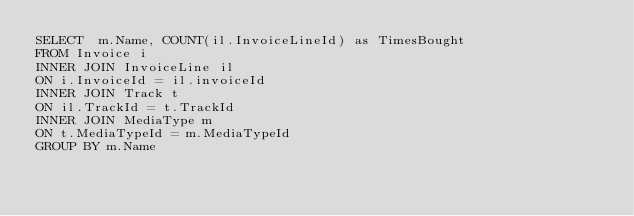Convert code to text. <code><loc_0><loc_0><loc_500><loc_500><_SQL_>SELECT  m.Name, COUNT(il.InvoiceLineId) as TimesBought
FROM Invoice i
INNER JOIN InvoiceLine il
ON i.InvoiceId = il.invoiceId
INNER JOIN Track t
ON il.TrackId = t.TrackId
INNER JOIN MediaType m
ON t.MediaTypeId = m.MediaTypeId
GROUP BY m.Name</code> 